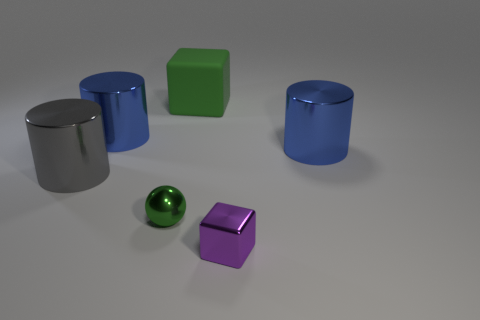Subtract all big gray cylinders. How many cylinders are left? 2 Subtract all brown cubes. How many blue cylinders are left? 2 Add 1 cylinders. How many objects exist? 7 Subtract all gray cylinders. How many cylinders are left? 2 Subtract all cubes. How many objects are left? 4 Subtract 1 cylinders. How many cylinders are left? 2 Subtract all purple blocks. Subtract all gray balls. How many blocks are left? 1 Subtract all large purple matte things. Subtract all metallic objects. How many objects are left? 1 Add 5 gray cylinders. How many gray cylinders are left? 6 Add 5 small metallic balls. How many small metallic balls exist? 6 